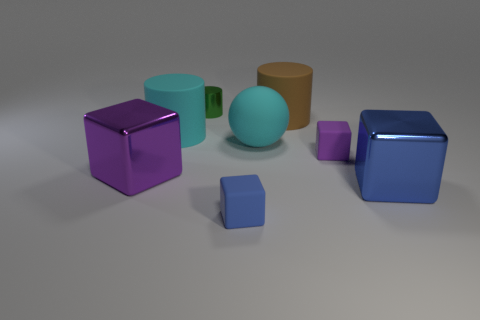What number of shiny objects are large blue blocks or cylinders?
Give a very brief answer. 2. The large thing that is in front of the big matte sphere and on the left side of the small green thing is made of what material?
Keep it short and to the point. Metal. There is a blue object that is on the left side of the purple thing that is behind the big purple object; are there any small purple objects in front of it?
Offer a very short reply. No. Is there anything else that has the same material as the large brown thing?
Make the answer very short. Yes. What is the shape of the tiny blue object that is the same material as the cyan ball?
Your answer should be very brief. Cube. Is the number of green cylinders to the left of the large blue shiny cube less than the number of big cyan rubber cylinders behind the brown matte cylinder?
Offer a terse response. No. How many tiny things are cyan shiny objects or blue cubes?
Keep it short and to the point. 1. Is the shape of the large cyan matte object that is right of the small green object the same as the cyan matte object that is on the left side of the green metallic cylinder?
Give a very brief answer. No. There is a metal thing right of the blue thing to the left of the cyan rubber thing that is on the right side of the cyan matte cylinder; what size is it?
Ensure brevity in your answer.  Large. There is a metallic thing that is behind the big cyan ball; what is its size?
Your answer should be compact. Small. 